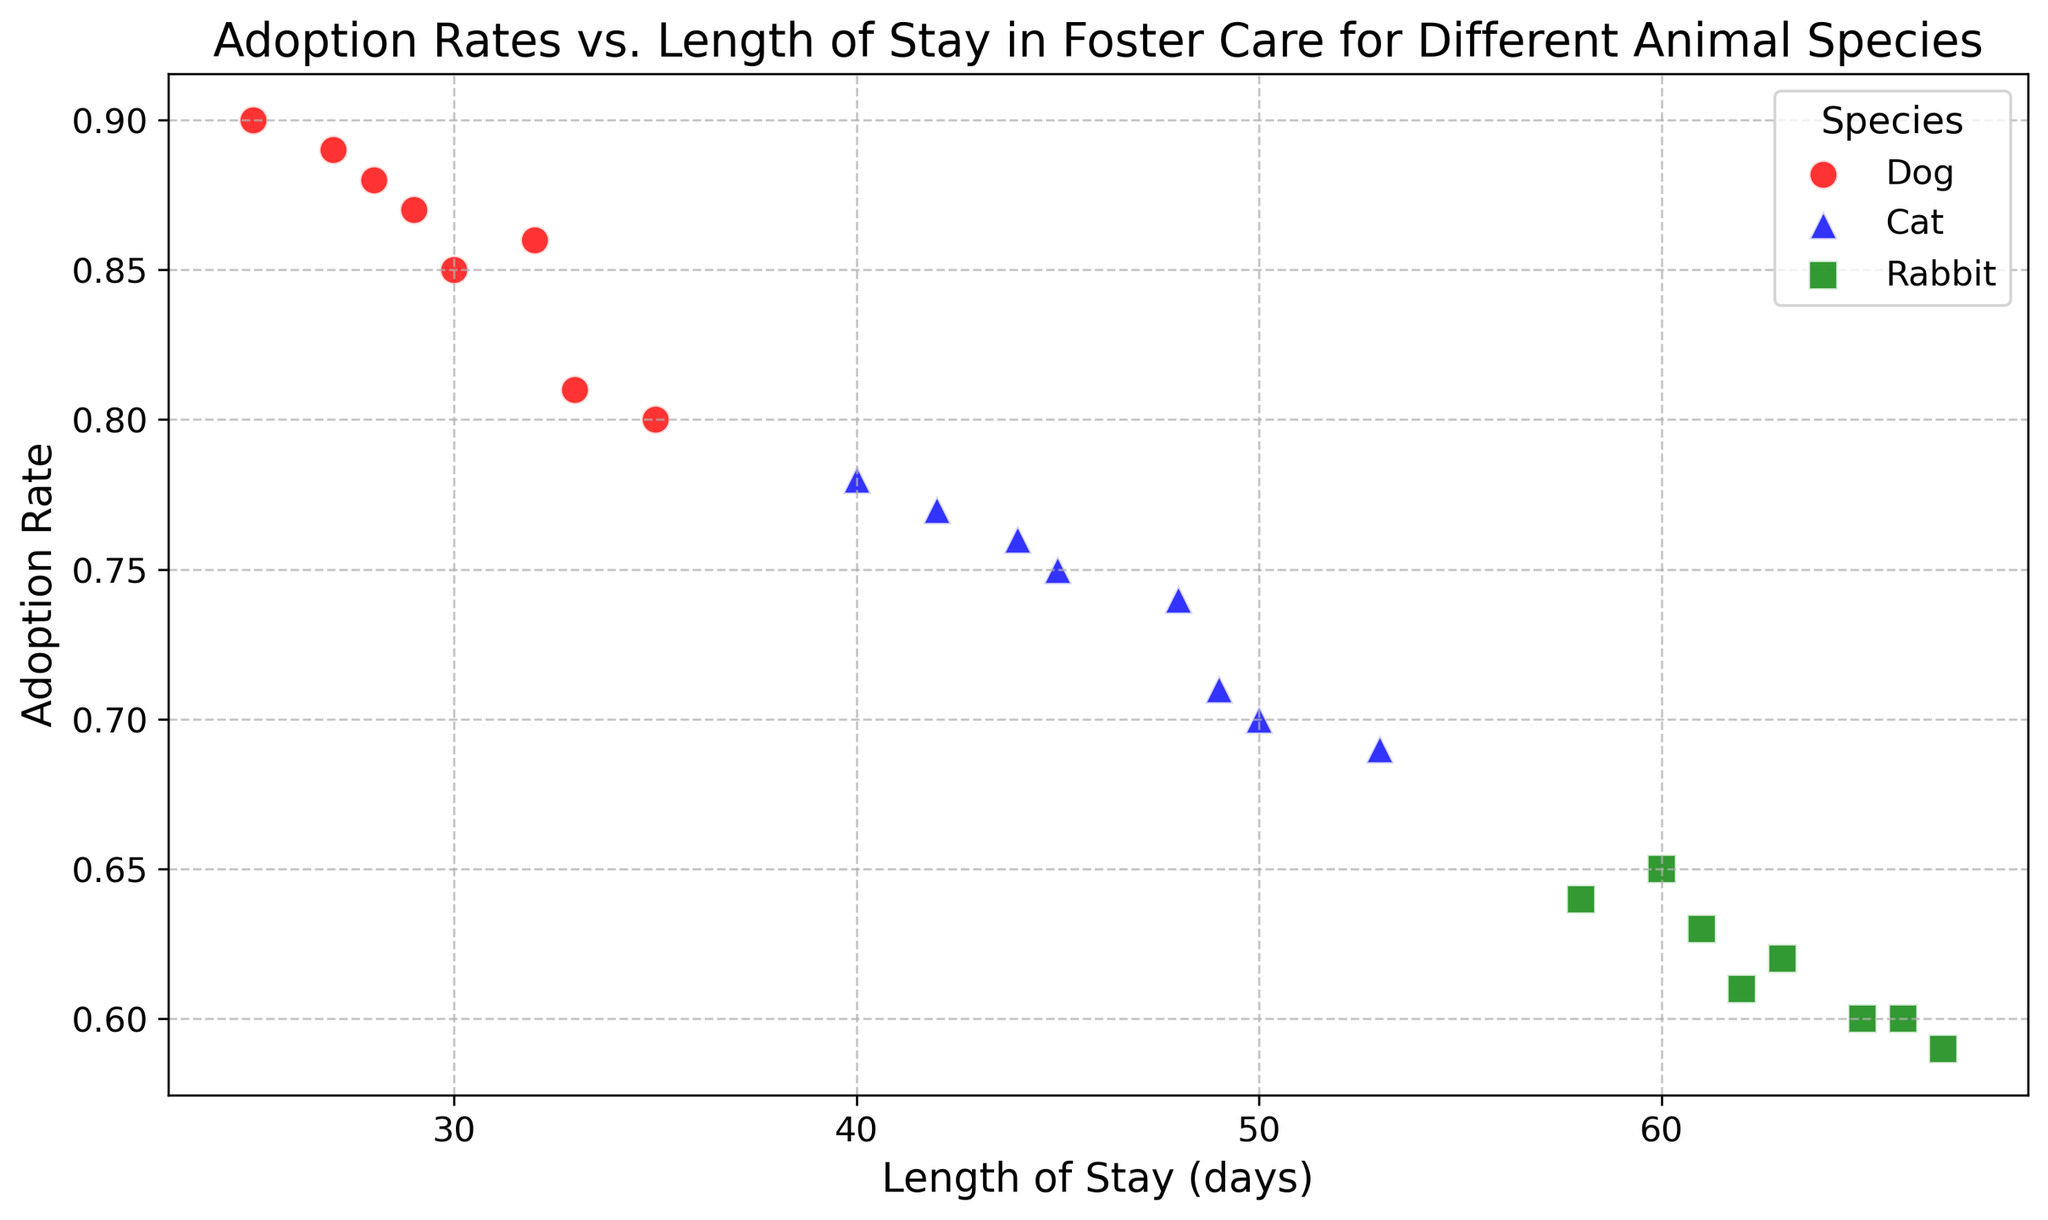What species has the highest adoption rate? To find the species with the highest adoption rate, locate the data points with the highest y-values (Adoption Rate) on the scatter plot.
Answer: Dog How long is the length of stay for the cat with the lowest adoption rate? Look for the cat data point with the lowest adoption rate (y-value) and then identify its corresponding x-value (Length of Stay).
Answer: 53 days Which species shows the most variability in the length of stay? Compare the spread (range) of the Length of Stay (x-values) for Dogs, Cats, and Rabbits. The species with the widest spread has the most variability.
Answer: Rabbit Which species has the lowest average adoption rate? Calculate the average adoption rate for Dogs, Cats, and Rabbits. Rabbits have consistently lower y-values (Adoption Rates) compared to Dogs and Cats.
Answer: Rabbit Is there an inverse relationship between Length of Stay and Adoption Rate for any species? Check if higher Length of Stay values correspond to lower Adoption Rates for any species by observing the trend direction for each species.
Answer: Yes, particularly for Rabbits Between cats and dogs, which species generally has a shorter length of stay? Compare the Length of Stay (x-values) for Cats and Dogs by observing which has data points more to the left within their species.
Answer: Dog On average, how much longer do rabbits stay in foster care compared to dogs? Compute the average Length of Stay for both Dogs and Rabbits, then find the difference between the two averages. (Average Length of Stay for Dogs is approximately 29.4 days, and for Rabbits, it's approximately 62.3 days).
Answer: 32.9 days Which species has data points clustered most closely together? Observe which species has data points that are tightly packed together for both Adoption Rate and Length of Stay dimensions.
Answer: Dog Are there any species for which the Adoption Rate does not go below 0.60? Check the lowest Adoption Rate (y-value) for each species. Dogs and Cats have Adoption Rates of at least 0.60.
Answer: Yes, Dogs and Cats Do longer lengths of stay always correspond to lower adoption rates for all species? Evaluate whether higher x-values consistently correspond to lower y-values for Dogs, Cats, and Rabbits.
Answer: No, not consistently 